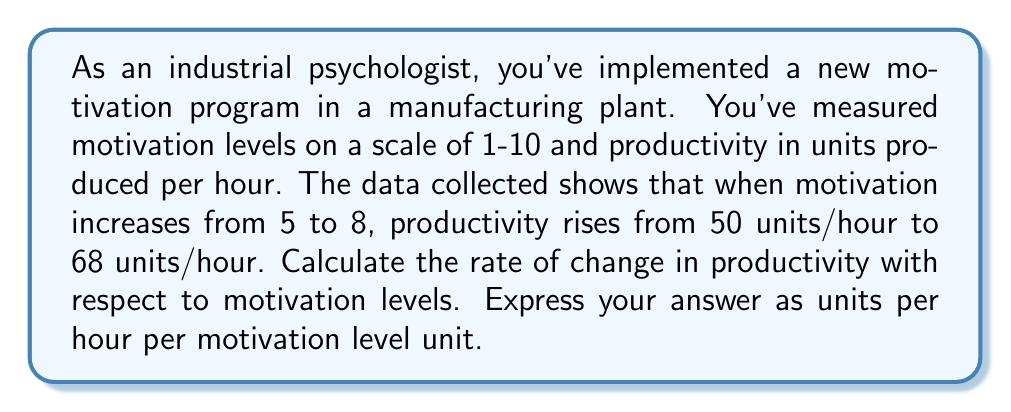Can you solve this math problem? To solve this problem, we need to calculate the rate of change in productivity with respect to motivation. This can be done using the slope formula:

$$\text{Rate of change} = \frac{\text{Change in productivity}}{\text{Change in motivation}}$$

Let's identify our values:
- Initial motivation level: $m_1 = 5$
- Final motivation level: $m_2 = 8$
- Initial productivity: $p_1 = 50$ units/hour
- Final productivity: $p_2 = 68$ units/hour

Now, let's calculate the changes:
- Change in motivation: $\Delta m = m_2 - m_1 = 8 - 5 = 3$
- Change in productivity: $\Delta p = p_2 - p_1 = 68 - 50 = 18$ units/hour

Plugging these values into our rate of change formula:

$$\text{Rate of change} = \frac{\Delta p}{\Delta m} = \frac{18 \text{ units/hour}}{3} = 6 \text{ units/hour per motivation level}$$

This means that for each unit increase in motivation level, productivity increases by 6 units per hour.
Answer: 6 units/hour per motivation level unit 